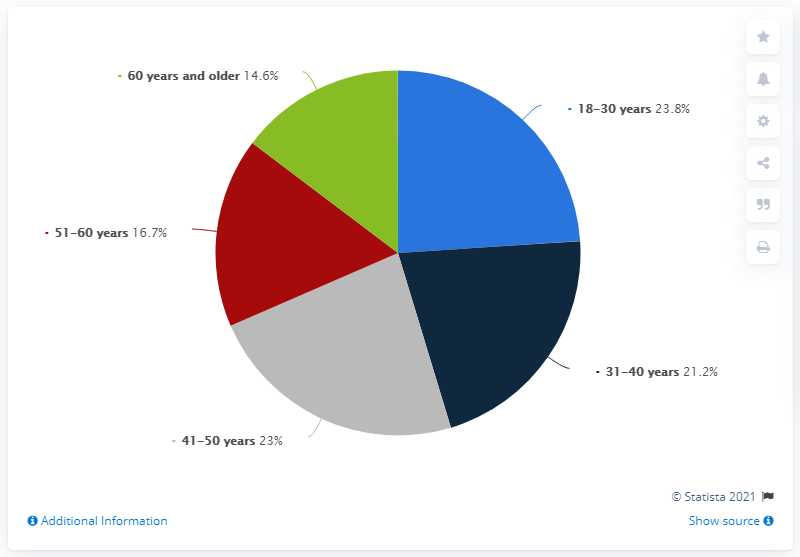18-30 year olds were scammed by how much percentage more than 31-40 year olds in Italy? The given answer of 2.6 does not correlate with the data represented in the image, which shows a pie chart with percentages for different age groups being scammed. To accurately derive a comparison, we would need to perform a calculation based on the pie chart segments. The image does not provide numerical data that allows for a precise calculation of the difference in percentages between the 18-30 and 31-40 year old groups in Italy. Without the exact figures, we cannot validate the answer of 2.6. 